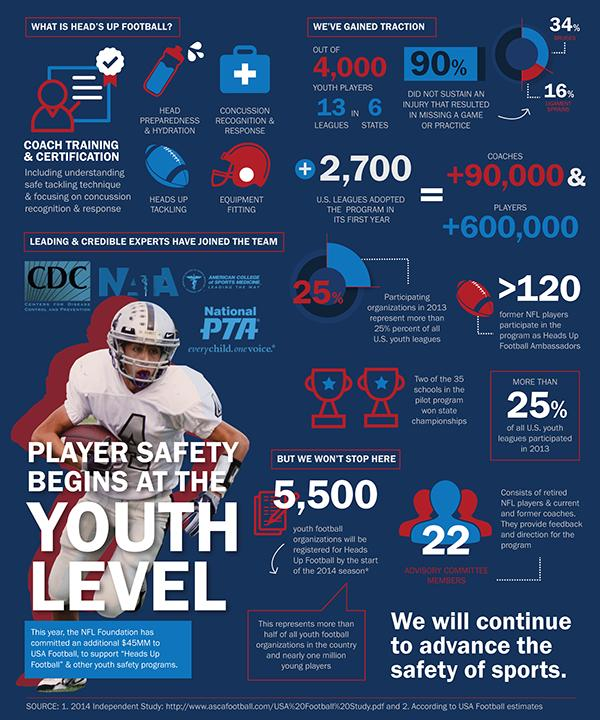Indicate a few pertinent items in this graphic. The advisory committee of Heads Up Football has 22 members. In the first year of its implementation, 2,700 U.S. leagues chose to adopt the 'Heads-Up Football' and other safety programs, demonstrating a commitment to player safety and a desire to promote best practices in football. By the start of the 2014 season, it is projected that 5,500 youth football organizations will have registered for Heads Up Football. 